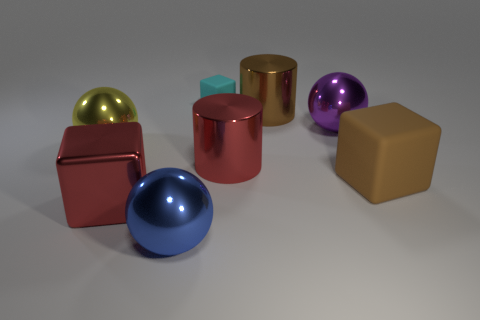Subtract all red blocks. How many blocks are left? 2 Subtract all yellow balls. How many balls are left? 2 Add 2 red cylinders. How many objects exist? 10 Subtract 1 cylinders. How many cylinders are left? 1 Subtract all brown blocks. Subtract all blue cylinders. How many blocks are left? 2 Subtract all blue blocks. How many green balls are left? 0 Subtract all big gray spheres. Subtract all big blue things. How many objects are left? 7 Add 3 red cubes. How many red cubes are left? 4 Add 2 cyan metal blocks. How many cyan metal blocks exist? 2 Subtract 1 red cylinders. How many objects are left? 7 